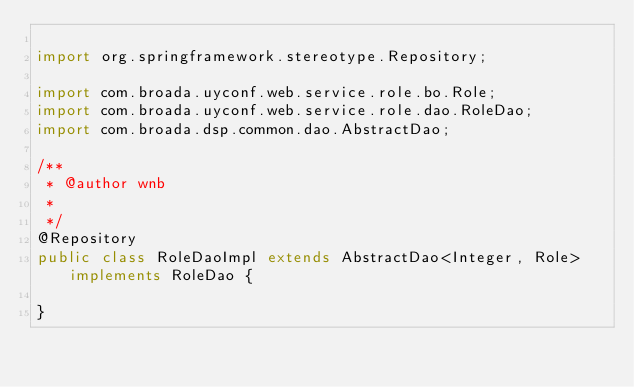<code> <loc_0><loc_0><loc_500><loc_500><_Java_>
import org.springframework.stereotype.Repository;

import com.broada.uyconf.web.service.role.bo.Role;
import com.broada.uyconf.web.service.role.dao.RoleDao;
import com.broada.dsp.common.dao.AbstractDao;

/**
 * @author wnb
 *
 */
@Repository
public class RoleDaoImpl extends AbstractDao<Integer, Role> implements RoleDao {

}
</code> 